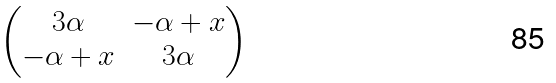Convert formula to latex. <formula><loc_0><loc_0><loc_500><loc_500>\begin{pmatrix} 3 \alpha & - \alpha + x \\ - \alpha + x & 3 \alpha \end{pmatrix}</formula> 